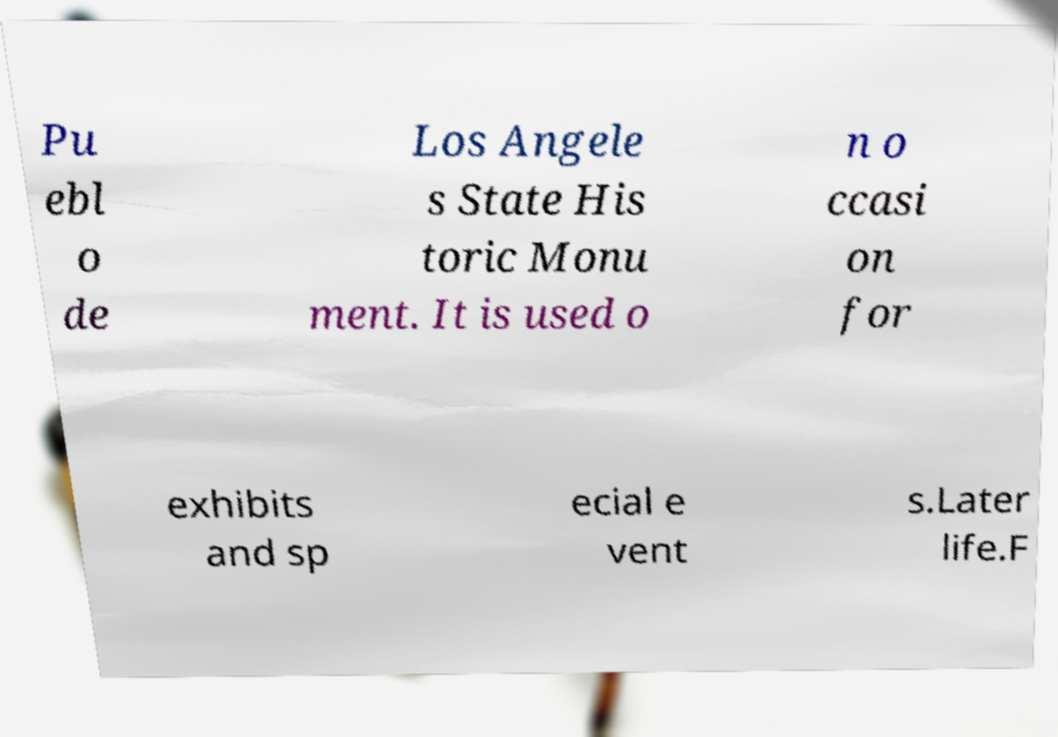What messages or text are displayed in this image? I need them in a readable, typed format. Pu ebl o de Los Angele s State His toric Monu ment. It is used o n o ccasi on for exhibits and sp ecial e vent s.Later life.F 